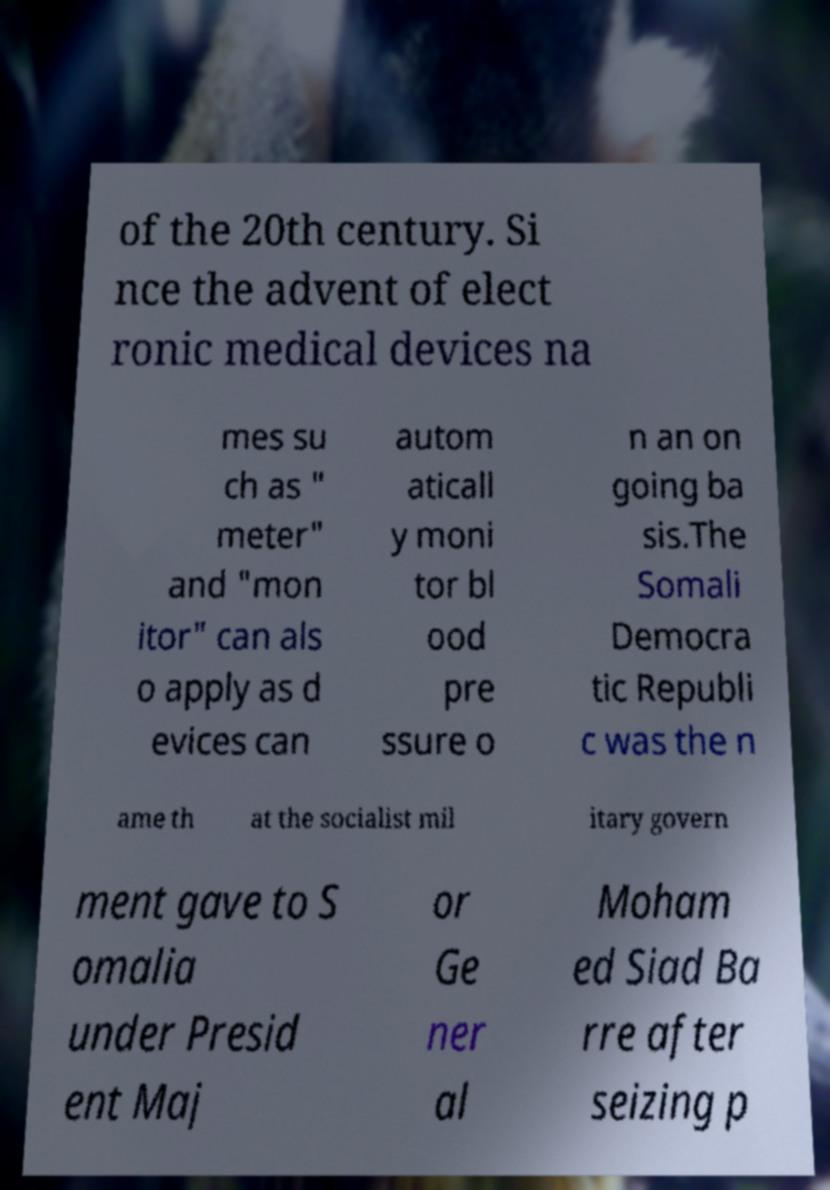There's text embedded in this image that I need extracted. Can you transcribe it verbatim? of the 20th century. Si nce the advent of elect ronic medical devices na mes su ch as " meter" and "mon itor" can als o apply as d evices can autom aticall y moni tor bl ood pre ssure o n an on going ba sis.The Somali Democra tic Republi c was the n ame th at the socialist mil itary govern ment gave to S omalia under Presid ent Maj or Ge ner al Moham ed Siad Ba rre after seizing p 